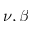Convert formula to latex. <formula><loc_0><loc_0><loc_500><loc_500>\nu , \beta</formula> 